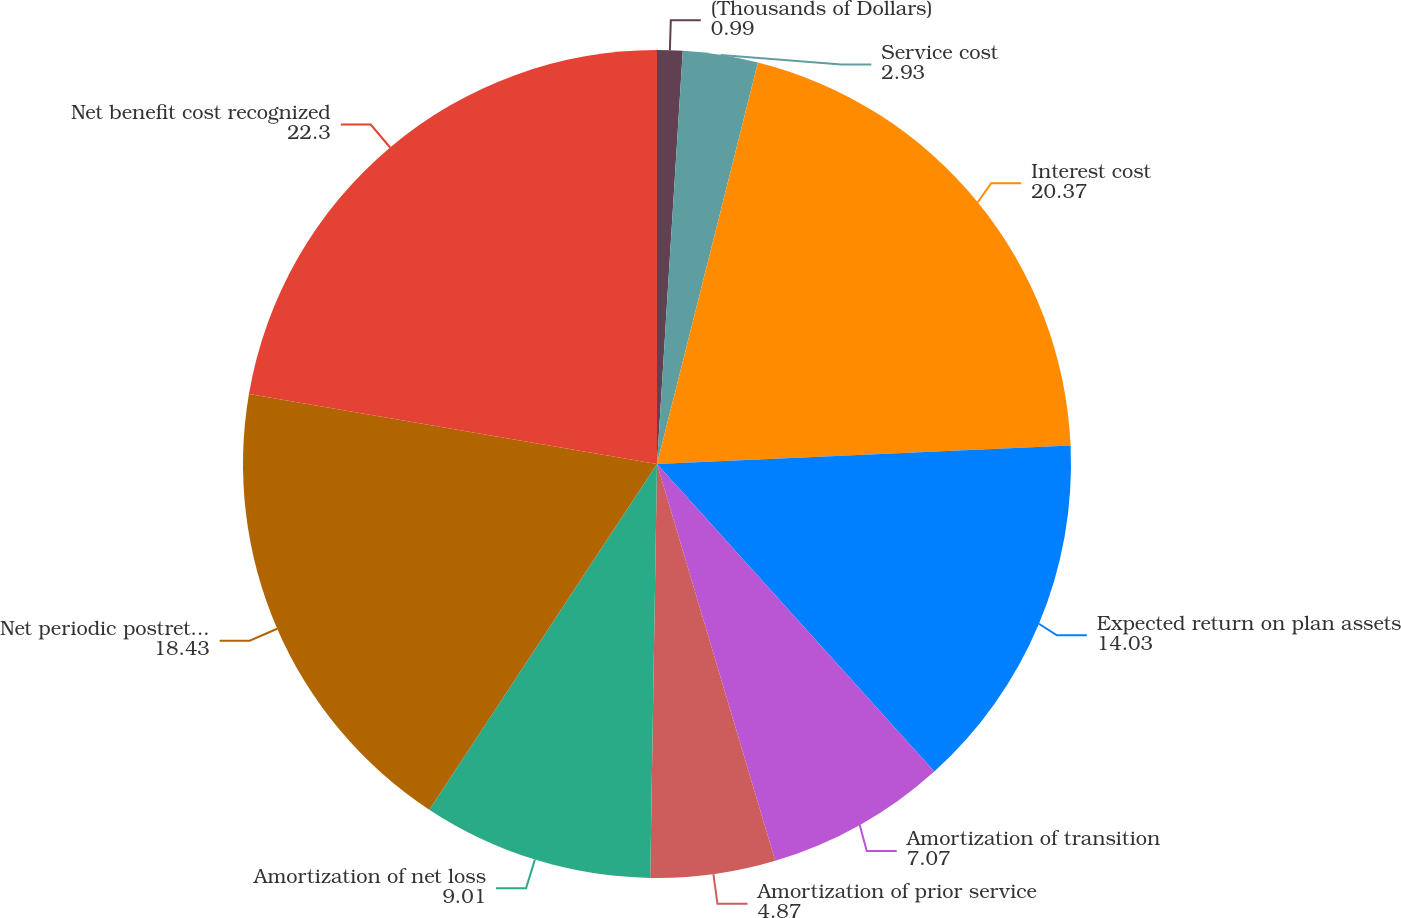Convert chart. <chart><loc_0><loc_0><loc_500><loc_500><pie_chart><fcel>(Thousands of Dollars)<fcel>Service cost<fcel>Interest cost<fcel>Expected return on plan assets<fcel>Amortization of transition<fcel>Amortization of prior service<fcel>Amortization of net loss<fcel>Net periodic postretirement<fcel>Net benefit cost recognized<nl><fcel>0.99%<fcel>2.93%<fcel>20.37%<fcel>14.03%<fcel>7.07%<fcel>4.87%<fcel>9.01%<fcel>18.43%<fcel>22.3%<nl></chart> 